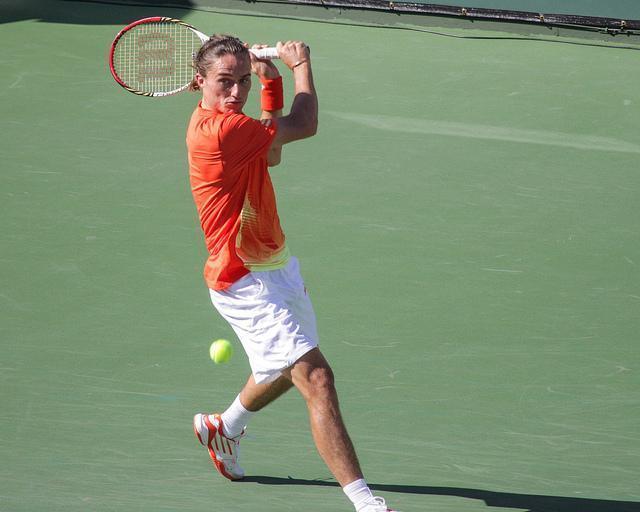How many tennis rackets can you see?
Give a very brief answer. 1. 